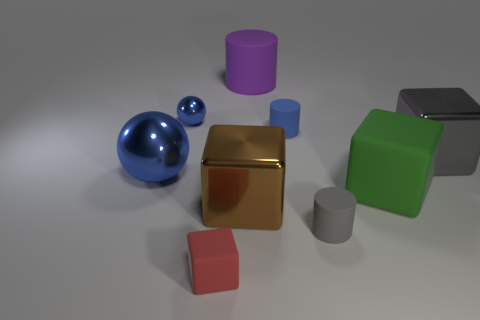Subtract 1 blocks. How many blocks are left? 3 Subtract all green blocks. How many blocks are left? 3 Subtract all big rubber blocks. How many blocks are left? 3 Add 1 big green shiny spheres. How many objects exist? 10 Subtract all cyan cubes. Subtract all red cylinders. How many cubes are left? 4 Add 1 purple cylinders. How many purple cylinders are left? 2 Add 7 large gray cubes. How many large gray cubes exist? 8 Subtract 0 green spheres. How many objects are left? 9 Subtract all cylinders. How many objects are left? 6 Subtract all shiny cubes. Subtract all purple cylinders. How many objects are left? 6 